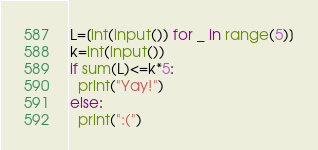Convert code to text. <code><loc_0><loc_0><loc_500><loc_500><_Python_>L=[int(input()) for _ in range(5)]
k=int(input())
if sum(L)<=k*5:
  print("Yay!")
else:
  print(":(")</code> 